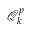<formula> <loc_0><loc_0><loc_500><loc_500>\mathcal { Q } _ { k } ^ { p }</formula> 